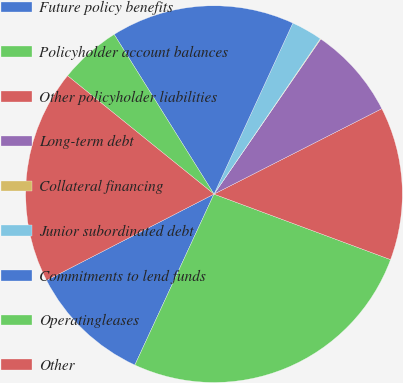<chart> <loc_0><loc_0><loc_500><loc_500><pie_chart><fcel>Future policy benefits<fcel>Policyholder account balances<fcel>Other policyholder liabilities<fcel>Long-term debt<fcel>Collateral financing<fcel>Junior subordinated debt<fcel>Commitments to lend funds<fcel>Operatingleases<fcel>Other<nl><fcel>10.53%<fcel>26.25%<fcel>13.15%<fcel>7.91%<fcel>0.05%<fcel>2.67%<fcel>15.77%<fcel>5.29%<fcel>18.39%<nl></chart> 